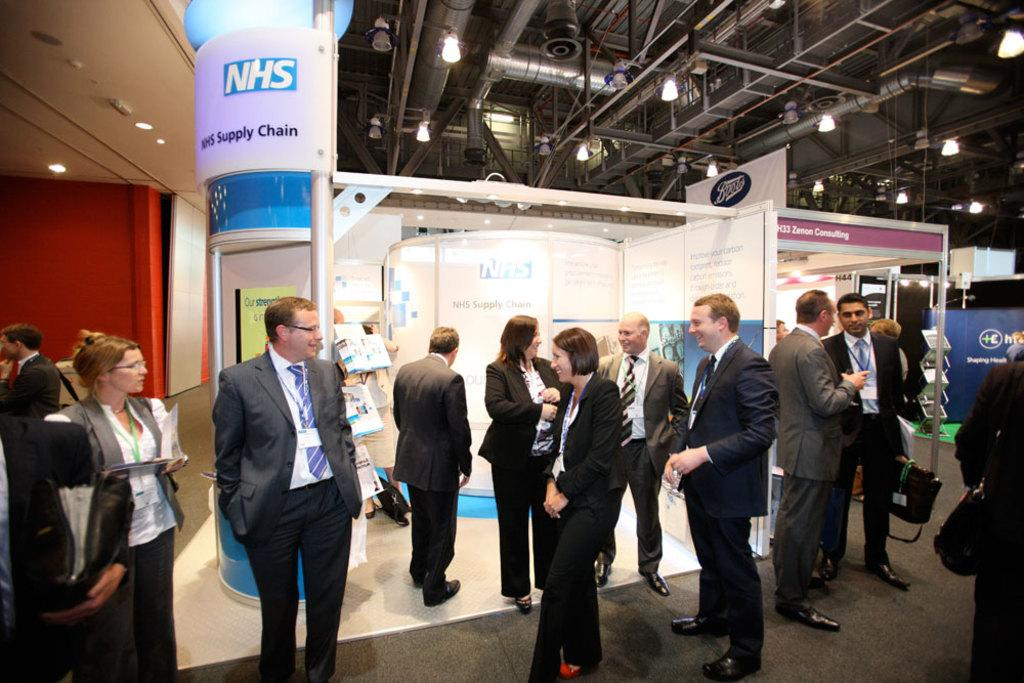What can be seen in the image involving people? There are people standing in the image. What type of signage is present in the image? There are advertisement boards in the image. What is hanging from the shed in the image? There are lights hanging from a shed in the image. What type of love can be seen in the image? There is no love present in the image; it features people standing and advertisement boards, as well as lights hanging from a shed. What is the price of the product being advertised on the boards in the image? The provided facts do not mention any specific product or price, so it cannot be determined from the image. 